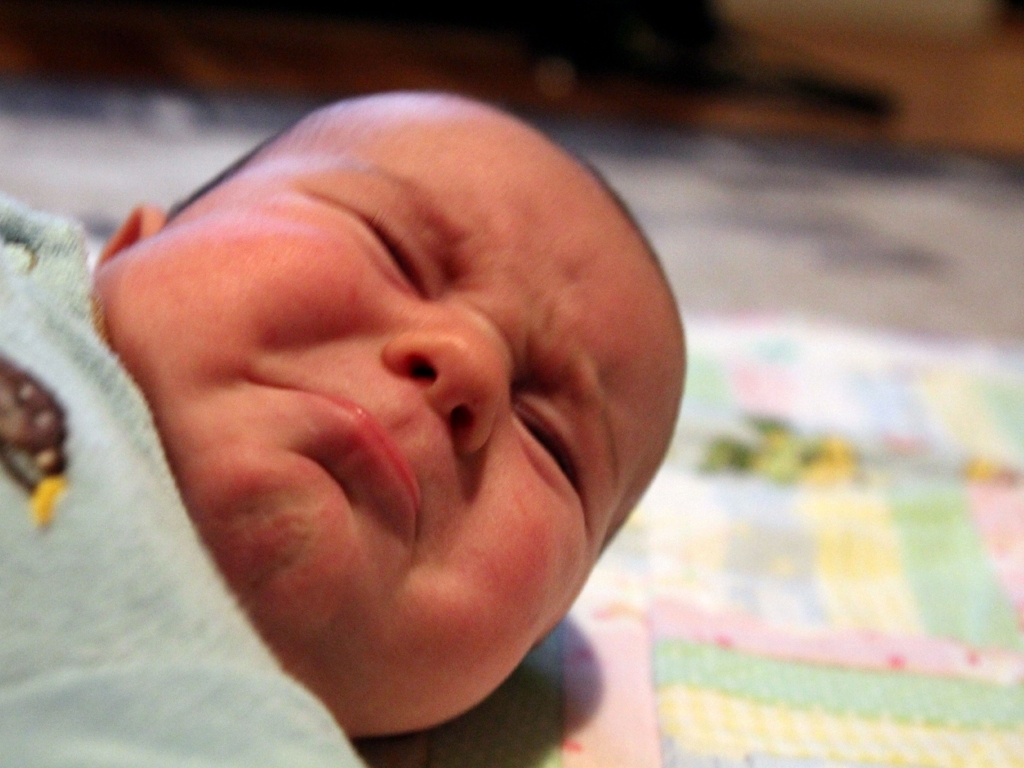Are there any noise and blurriness in the image? The image shows a certain level of graininess or 'noise,' particularly noticeable in lower-light areas such as the background. There is also some softness in the focus, giving a perception of slight blurriness, particularly around the newborn's facial features. 